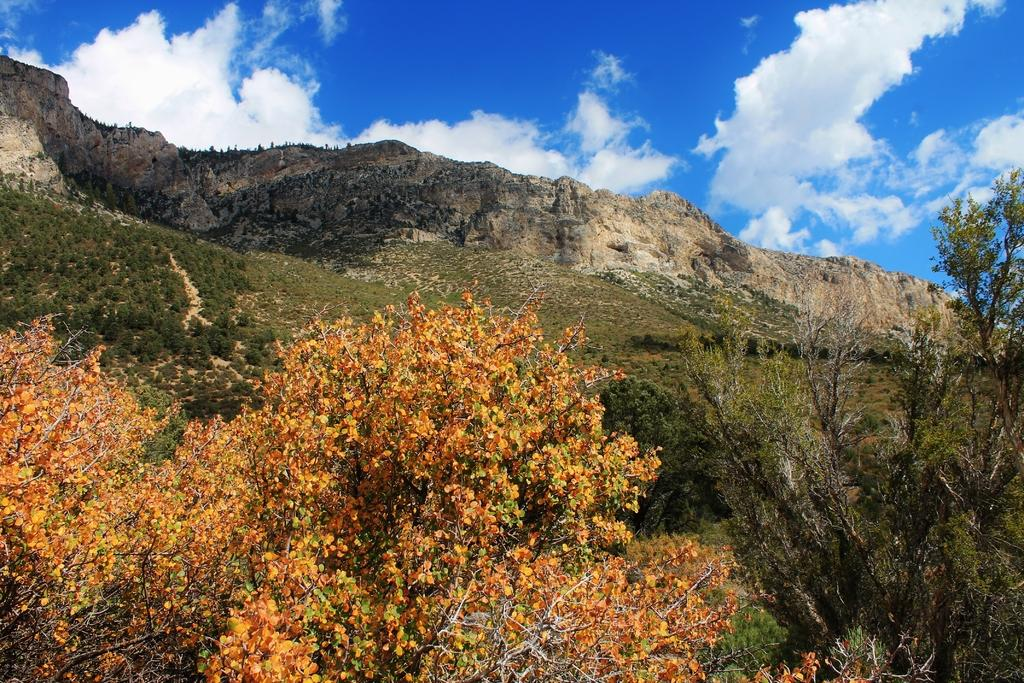What type of natural elements can be seen on the ground in the image? There are trees and plants on the ground in the image. What type of geological features can be seen in the background of the image? There are rocks in the background of the image. What is visible in the sky in the image? The sky is visible in the background of the image. What can be observed in the sky besides the sky itself? Clouds are present in the sky. What color is the thumb that is holding the orange on the stage in the image? There is no thumb, orange, or stage present in the image. 